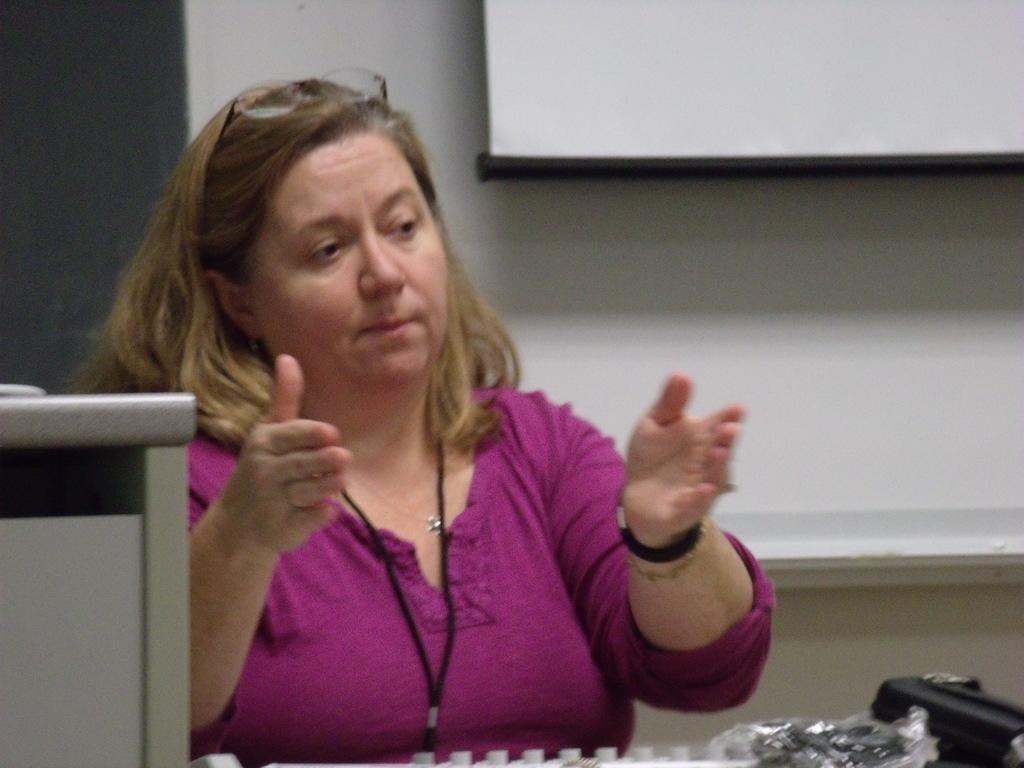Who is present in the image? There is a woman in the image. What is the woman wearing? The woman is wearing clothes, a neck chain, and a bracelet. What can be seen in the image besides the woman? There is a spectacle, a white chart, and other objects in the image. How many cows are visible in the image? There are no cows present in the image. What is the woman's tendency in the image? The provided facts do not give any information about the woman's tendencies or behavior. --- 